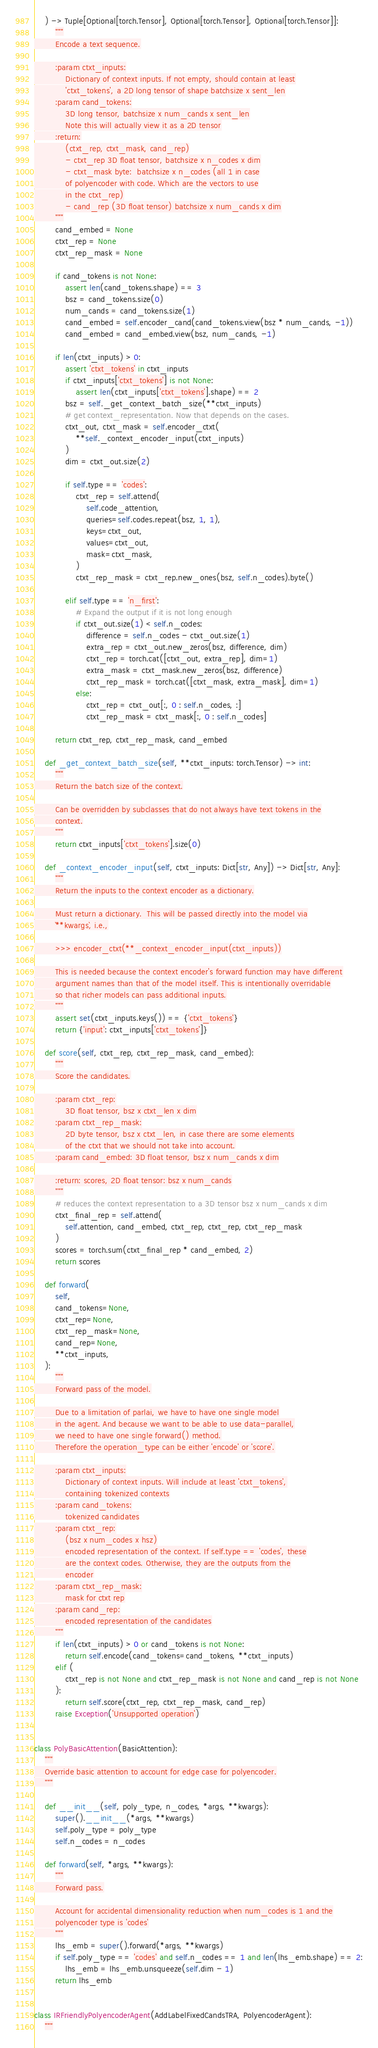<code> <loc_0><loc_0><loc_500><loc_500><_Python_>    ) -> Tuple[Optional[torch.Tensor], Optional[torch.Tensor], Optional[torch.Tensor]]:
        """
        Encode a text sequence.

        :param ctxt_inputs:
            Dictionary of context inputs. If not empty, should contain at least
            'ctxt_tokens', a 2D long tensor of shape batchsize x sent_len
        :param cand_tokens:
            3D long tensor, batchsize x num_cands x sent_len
            Note this will actually view it as a 2D tensor
        :return:
            (ctxt_rep, ctxt_mask, cand_rep)
            - ctxt_rep 3D float tensor, batchsize x n_codes x dim
            - ctxt_mask byte:  batchsize x n_codes (all 1 in case
            of polyencoder with code. Which are the vectors to use
            in the ctxt_rep)
            - cand_rep (3D float tensor) batchsize x num_cands x dim
        """
        cand_embed = None
        ctxt_rep = None
        ctxt_rep_mask = None

        if cand_tokens is not None:
            assert len(cand_tokens.shape) == 3
            bsz = cand_tokens.size(0)
            num_cands = cand_tokens.size(1)
            cand_embed = self.encoder_cand(cand_tokens.view(bsz * num_cands, -1))
            cand_embed = cand_embed.view(bsz, num_cands, -1)

        if len(ctxt_inputs) > 0:
            assert 'ctxt_tokens' in ctxt_inputs
            if ctxt_inputs['ctxt_tokens'] is not None:
                assert len(ctxt_inputs['ctxt_tokens'].shape) == 2
            bsz = self._get_context_batch_size(**ctxt_inputs)
            # get context_representation. Now that depends on the cases.
            ctxt_out, ctxt_mask = self.encoder_ctxt(
                **self._context_encoder_input(ctxt_inputs)
            )
            dim = ctxt_out.size(2)

            if self.type == 'codes':
                ctxt_rep = self.attend(
                    self.code_attention,
                    queries=self.codes.repeat(bsz, 1, 1),
                    keys=ctxt_out,
                    values=ctxt_out,
                    mask=ctxt_mask,
                )
                ctxt_rep_mask = ctxt_rep.new_ones(bsz, self.n_codes).byte()

            elif self.type == 'n_first':
                # Expand the output if it is not long enough
                if ctxt_out.size(1) < self.n_codes:
                    difference = self.n_codes - ctxt_out.size(1)
                    extra_rep = ctxt_out.new_zeros(bsz, difference, dim)
                    ctxt_rep = torch.cat([ctxt_out, extra_rep], dim=1)
                    extra_mask = ctxt_mask.new_zeros(bsz, difference)
                    ctxt_rep_mask = torch.cat([ctxt_mask, extra_mask], dim=1)
                else:
                    ctxt_rep = ctxt_out[:, 0 : self.n_codes, :]
                    ctxt_rep_mask = ctxt_mask[:, 0 : self.n_codes]

        return ctxt_rep, ctxt_rep_mask, cand_embed

    def _get_context_batch_size(self, **ctxt_inputs: torch.Tensor) -> int:
        """
        Return the batch size of the context.

        Can be overridden by subclasses that do not always have text tokens in the
        context.
        """
        return ctxt_inputs['ctxt_tokens'].size(0)

    def _context_encoder_input(self, ctxt_inputs: Dict[str, Any]) -> Dict[str, Any]:
        """
        Return the inputs to the context encoder as a dictionary.

        Must return a dictionary.  This will be passed directly into the model via
        `**kwargs`, i.e.,

        >>> encoder_ctxt(**_context_encoder_input(ctxt_inputs))

        This is needed because the context encoder's forward function may have different
        argument names than that of the model itself. This is intentionally overridable
        so that richer models can pass additional inputs.
        """
        assert set(ctxt_inputs.keys()) == {'ctxt_tokens'}
        return {'input': ctxt_inputs['ctxt_tokens']}

    def score(self, ctxt_rep, ctxt_rep_mask, cand_embed):
        """
        Score the candidates.

        :param ctxt_rep:
            3D float tensor, bsz x ctxt_len x dim
        :param ctxt_rep_mask:
            2D byte tensor, bsz x ctxt_len, in case there are some elements
            of the ctxt that we should not take into account.
        :param cand_embed: 3D float tensor, bsz x num_cands x dim

        :return: scores, 2D float tensor: bsz x num_cands
        """
        # reduces the context representation to a 3D tensor bsz x num_cands x dim
        ctxt_final_rep = self.attend(
            self.attention, cand_embed, ctxt_rep, ctxt_rep, ctxt_rep_mask
        )
        scores = torch.sum(ctxt_final_rep * cand_embed, 2)
        return scores

    def forward(
        self,
        cand_tokens=None,
        ctxt_rep=None,
        ctxt_rep_mask=None,
        cand_rep=None,
        **ctxt_inputs,
    ):
        """
        Forward pass of the model.

        Due to a limitation of parlai, we have to have one single model
        in the agent. And because we want to be able to use data-parallel,
        we need to have one single forward() method.
        Therefore the operation_type can be either 'encode' or 'score'.

        :param ctxt_inputs:
            Dictionary of context inputs. Will include at least 'ctxt_tokens',
            containing tokenized contexts
        :param cand_tokens:
            tokenized candidates
        :param ctxt_rep:
            (bsz x num_codes x hsz)
            encoded representation of the context. If self.type == 'codes', these
            are the context codes. Otherwise, they are the outputs from the
            encoder
        :param ctxt_rep_mask:
            mask for ctxt rep
        :param cand_rep:
            encoded representation of the candidates
        """
        if len(ctxt_inputs) > 0 or cand_tokens is not None:
            return self.encode(cand_tokens=cand_tokens, **ctxt_inputs)
        elif (
            ctxt_rep is not None and ctxt_rep_mask is not None and cand_rep is not None
        ):
            return self.score(ctxt_rep, ctxt_rep_mask, cand_rep)
        raise Exception('Unsupported operation')


class PolyBasicAttention(BasicAttention):
    """
    Override basic attention to account for edge case for polyencoder.
    """

    def __init__(self, poly_type, n_codes, *args, **kwargs):
        super().__init__(*args, **kwargs)
        self.poly_type = poly_type
        self.n_codes = n_codes

    def forward(self, *args, **kwargs):
        """
        Forward pass.

        Account for accidental dimensionality reduction when num_codes is 1 and the
        polyencoder type is 'codes'
        """
        lhs_emb = super().forward(*args, **kwargs)
        if self.poly_type == 'codes' and self.n_codes == 1 and len(lhs_emb.shape) == 2:
            lhs_emb = lhs_emb.unsqueeze(self.dim - 1)
        return lhs_emb


class IRFriendlyPolyencoderAgent(AddLabelFixedCandsTRA, PolyencoderAgent):
    """</code> 